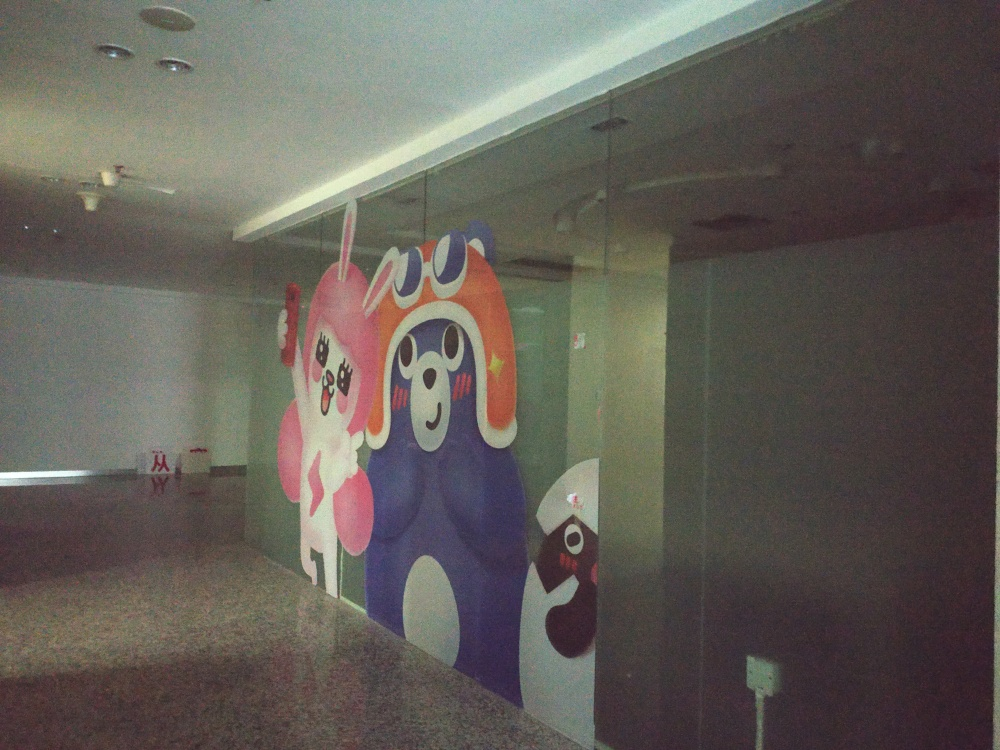What is the style of the artwork depicted on the advertising glass? The artwork behind the glass showcases a style that is cartoonish and whimsical. The characters are drawn with exaggerated features, bold outlines, and a bright color palette, which gives them a playful and inviting aesthetic reminiscent of modern animation or pop art. 